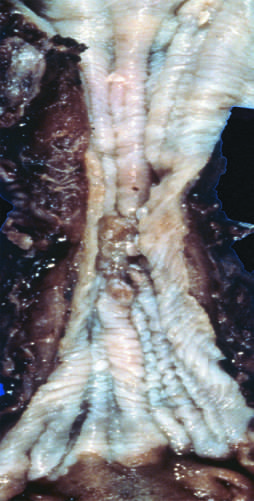what is found in the mid-esophagus, where it commonly causes strictures?
Answer the question using a single word or phrase. Squamous cell carcinoma 